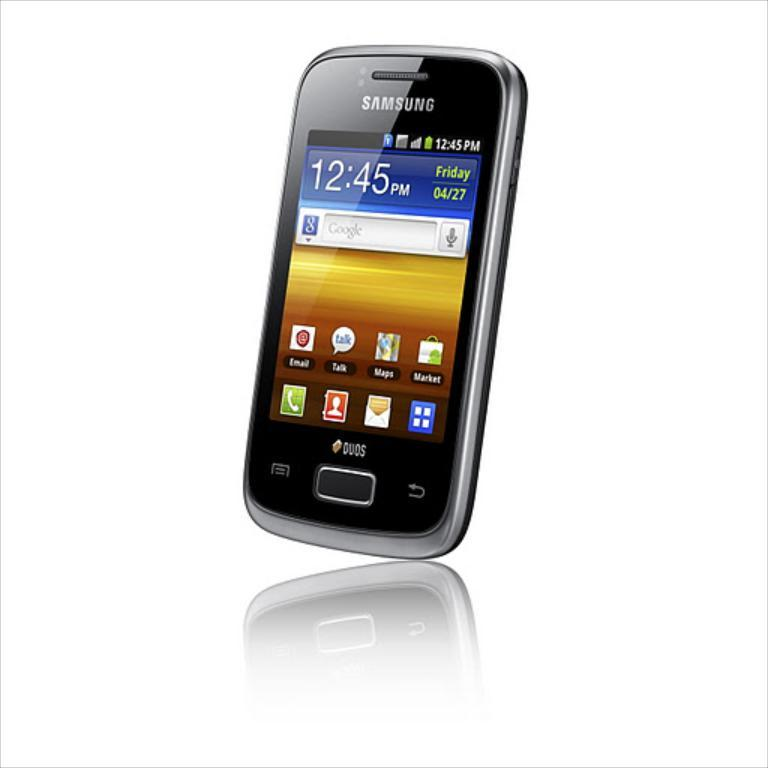<image>
Describe the image concisely. A Samsung phone shows email, talk, and map icons. 